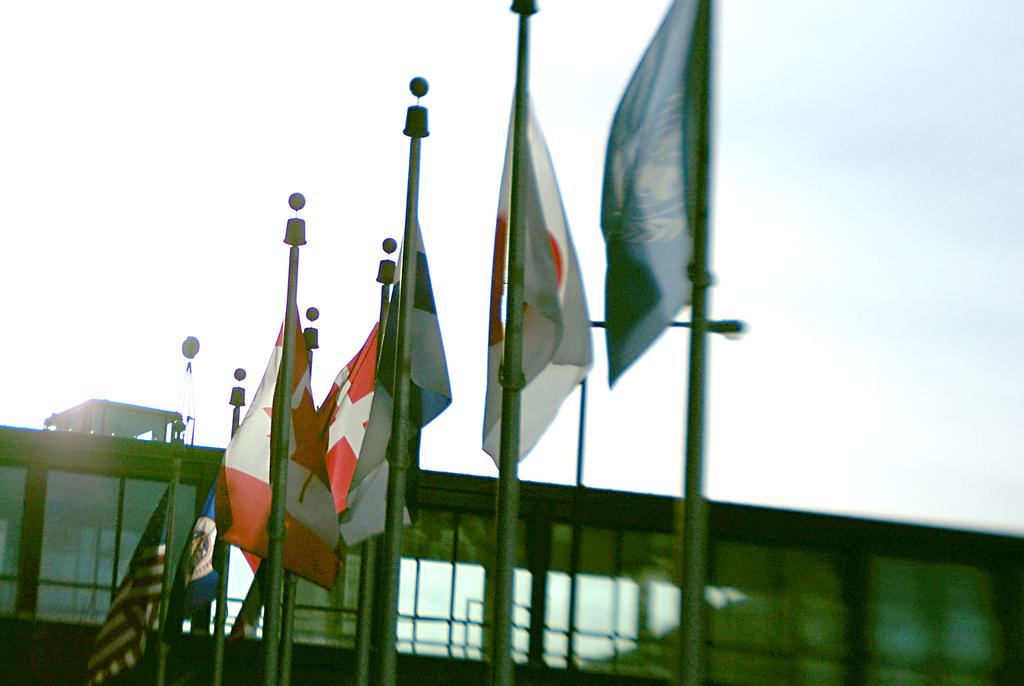What is located in the foreground of the image? There are flags in the foreground of the image. What type of structure can be seen in the bottom background of the image? There is a building in the bottom background of the image. What is visible at the top of the image? The sky is visible at the top of the image. How many plastic mailboxes are attached to the building in the image? There is no mention of plastic mailboxes in the image, and therefore no such objects can be observed. 